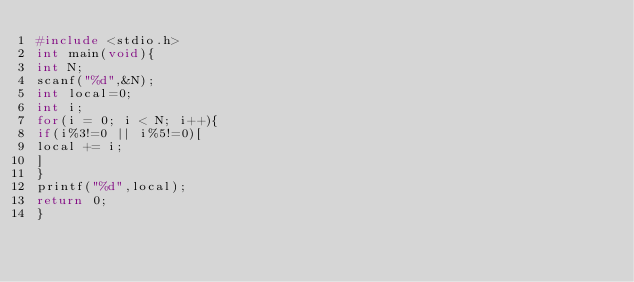<code> <loc_0><loc_0><loc_500><loc_500><_C_>#include <stdio.h>
int main(void){
int N;
scanf("%d",&N);
int local=0;
int i;
for(i = 0; i < N; i++){
if(i%3!=0 || i%5!=0)[
local += i;
]
}
printf("%d",local);
return 0;
}
</code> 